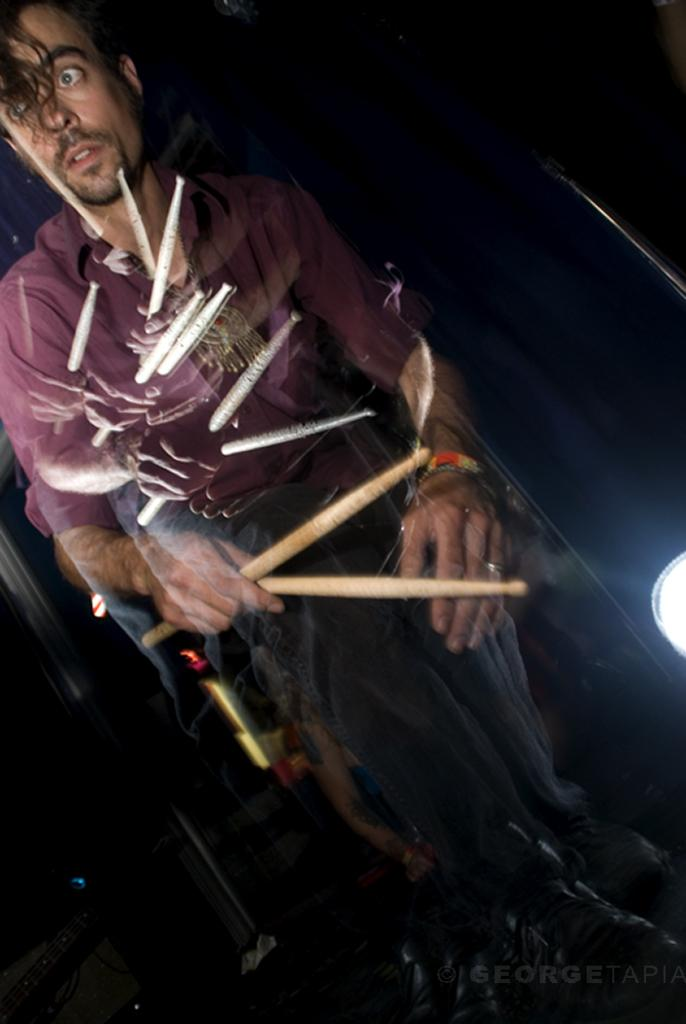Who is present in the image? There is a man in the image. What is the man holding in the image? The man is holding sticks. Can you describe the lighting in the image? There is a light beside the man. What type of butter is being used on the sofa in the image? There is no butter or sofa present in the image; it only features a man holding sticks and a light beside him. 